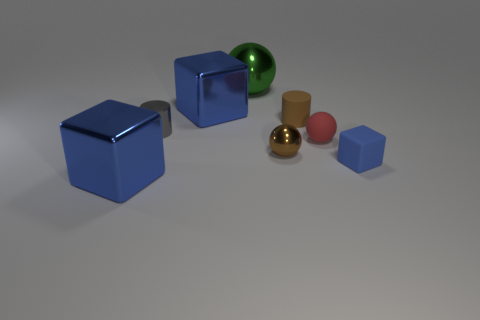What number of other objects are there of the same color as the matte ball?
Ensure brevity in your answer.  0. There is a large green sphere; are there any small brown things in front of it?
Provide a short and direct response. Yes. What number of other blue rubber things have the same shape as the small blue rubber thing?
Keep it short and to the point. 0. There is a metal block that is left of the metallic cube behind the big blue object in front of the tiny blue matte block; what color is it?
Your answer should be compact. Blue. Is the material of the blue block to the left of the gray shiny cylinder the same as the cylinder to the left of the green shiny sphere?
Give a very brief answer. Yes. How many objects are metallic blocks behind the small red matte thing or purple metal blocks?
Provide a succinct answer. 1. What number of things are small red things or things that are to the left of the blue rubber thing?
Offer a very short reply. 7. How many brown metallic balls have the same size as the gray shiny cylinder?
Keep it short and to the point. 1. Are there fewer small blue rubber cubes that are behind the matte cube than tiny rubber things that are behind the brown matte cylinder?
Your answer should be compact. No. What number of shiny things are either big spheres or gray objects?
Your answer should be very brief. 2. 